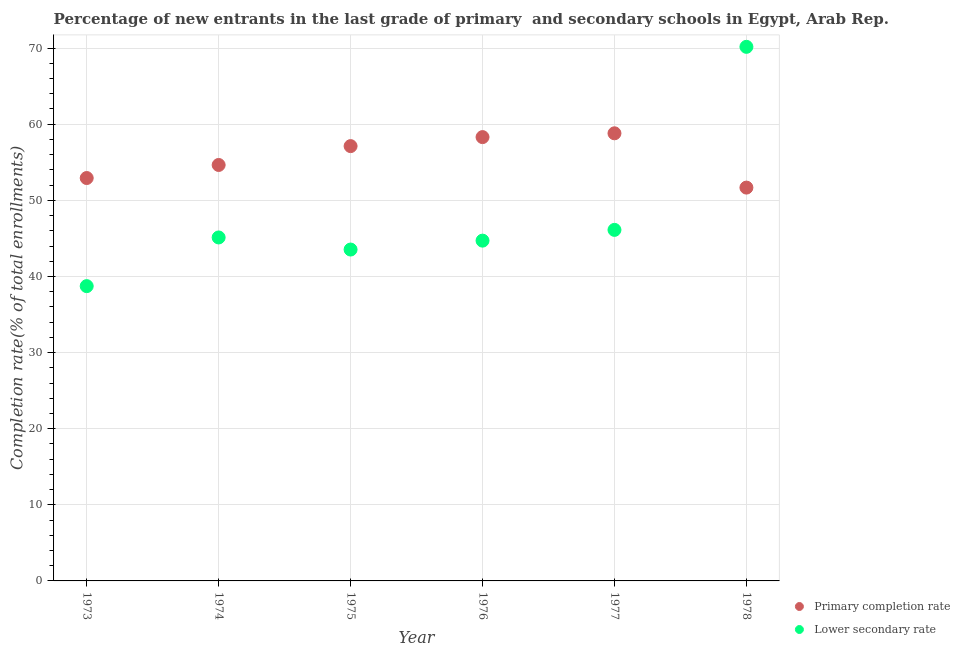What is the completion rate in secondary schools in 1975?
Ensure brevity in your answer.  43.53. Across all years, what is the maximum completion rate in secondary schools?
Your answer should be compact. 70.17. Across all years, what is the minimum completion rate in secondary schools?
Make the answer very short. 38.73. In which year was the completion rate in secondary schools maximum?
Your answer should be compact. 1978. In which year was the completion rate in primary schools minimum?
Your response must be concise. 1978. What is the total completion rate in secondary schools in the graph?
Offer a very short reply. 288.37. What is the difference between the completion rate in secondary schools in 1973 and that in 1976?
Keep it short and to the point. -5.98. What is the difference between the completion rate in secondary schools in 1976 and the completion rate in primary schools in 1977?
Keep it short and to the point. -14.1. What is the average completion rate in secondary schools per year?
Your answer should be very brief. 48.06. In the year 1975, what is the difference between the completion rate in secondary schools and completion rate in primary schools?
Keep it short and to the point. -13.59. In how many years, is the completion rate in secondary schools greater than 10 %?
Your answer should be compact. 6. What is the ratio of the completion rate in secondary schools in 1973 to that in 1975?
Your response must be concise. 0.89. What is the difference between the highest and the second highest completion rate in secondary schools?
Make the answer very short. 24.05. What is the difference between the highest and the lowest completion rate in primary schools?
Offer a terse response. 7.13. Does the completion rate in secondary schools monotonically increase over the years?
Offer a very short reply. No. Is the completion rate in secondary schools strictly greater than the completion rate in primary schools over the years?
Offer a terse response. No. Does the graph contain any zero values?
Your answer should be compact. No. Does the graph contain grids?
Your response must be concise. Yes. Where does the legend appear in the graph?
Your response must be concise. Bottom right. How many legend labels are there?
Your answer should be very brief. 2. What is the title of the graph?
Offer a terse response. Percentage of new entrants in the last grade of primary  and secondary schools in Egypt, Arab Rep. What is the label or title of the Y-axis?
Provide a succinct answer. Completion rate(% of total enrollments). What is the Completion rate(% of total enrollments) of Primary completion rate in 1973?
Provide a succinct answer. 52.93. What is the Completion rate(% of total enrollments) in Lower secondary rate in 1973?
Make the answer very short. 38.73. What is the Completion rate(% of total enrollments) in Primary completion rate in 1974?
Your response must be concise. 54.65. What is the Completion rate(% of total enrollments) in Lower secondary rate in 1974?
Your answer should be compact. 45.12. What is the Completion rate(% of total enrollments) of Primary completion rate in 1975?
Provide a succinct answer. 57.12. What is the Completion rate(% of total enrollments) in Lower secondary rate in 1975?
Provide a short and direct response. 43.53. What is the Completion rate(% of total enrollments) of Primary completion rate in 1976?
Make the answer very short. 58.31. What is the Completion rate(% of total enrollments) of Lower secondary rate in 1976?
Your response must be concise. 44.7. What is the Completion rate(% of total enrollments) in Primary completion rate in 1977?
Give a very brief answer. 58.81. What is the Completion rate(% of total enrollments) of Lower secondary rate in 1977?
Keep it short and to the point. 46.12. What is the Completion rate(% of total enrollments) of Primary completion rate in 1978?
Your answer should be very brief. 51.67. What is the Completion rate(% of total enrollments) in Lower secondary rate in 1978?
Your answer should be compact. 70.17. Across all years, what is the maximum Completion rate(% of total enrollments) in Primary completion rate?
Make the answer very short. 58.81. Across all years, what is the maximum Completion rate(% of total enrollments) in Lower secondary rate?
Offer a terse response. 70.17. Across all years, what is the minimum Completion rate(% of total enrollments) of Primary completion rate?
Keep it short and to the point. 51.67. Across all years, what is the minimum Completion rate(% of total enrollments) in Lower secondary rate?
Keep it short and to the point. 38.73. What is the total Completion rate(% of total enrollments) of Primary completion rate in the graph?
Your answer should be compact. 333.48. What is the total Completion rate(% of total enrollments) in Lower secondary rate in the graph?
Your answer should be very brief. 288.37. What is the difference between the Completion rate(% of total enrollments) in Primary completion rate in 1973 and that in 1974?
Make the answer very short. -1.72. What is the difference between the Completion rate(% of total enrollments) in Lower secondary rate in 1973 and that in 1974?
Keep it short and to the point. -6.39. What is the difference between the Completion rate(% of total enrollments) of Primary completion rate in 1973 and that in 1975?
Your answer should be very brief. -4.19. What is the difference between the Completion rate(% of total enrollments) of Lower secondary rate in 1973 and that in 1975?
Offer a very short reply. -4.81. What is the difference between the Completion rate(% of total enrollments) in Primary completion rate in 1973 and that in 1976?
Ensure brevity in your answer.  -5.38. What is the difference between the Completion rate(% of total enrollments) of Lower secondary rate in 1973 and that in 1976?
Provide a succinct answer. -5.98. What is the difference between the Completion rate(% of total enrollments) in Primary completion rate in 1973 and that in 1977?
Give a very brief answer. -5.88. What is the difference between the Completion rate(% of total enrollments) in Lower secondary rate in 1973 and that in 1977?
Make the answer very short. -7.39. What is the difference between the Completion rate(% of total enrollments) in Primary completion rate in 1973 and that in 1978?
Keep it short and to the point. 1.26. What is the difference between the Completion rate(% of total enrollments) in Lower secondary rate in 1973 and that in 1978?
Give a very brief answer. -31.44. What is the difference between the Completion rate(% of total enrollments) of Primary completion rate in 1974 and that in 1975?
Offer a very short reply. -2.48. What is the difference between the Completion rate(% of total enrollments) in Lower secondary rate in 1974 and that in 1975?
Give a very brief answer. 1.59. What is the difference between the Completion rate(% of total enrollments) in Primary completion rate in 1974 and that in 1976?
Ensure brevity in your answer.  -3.66. What is the difference between the Completion rate(% of total enrollments) of Lower secondary rate in 1974 and that in 1976?
Offer a very short reply. 0.42. What is the difference between the Completion rate(% of total enrollments) of Primary completion rate in 1974 and that in 1977?
Provide a short and direct response. -4.16. What is the difference between the Completion rate(% of total enrollments) of Lower secondary rate in 1974 and that in 1977?
Your answer should be very brief. -0.99. What is the difference between the Completion rate(% of total enrollments) in Primary completion rate in 1974 and that in 1978?
Keep it short and to the point. 2.97. What is the difference between the Completion rate(% of total enrollments) in Lower secondary rate in 1974 and that in 1978?
Make the answer very short. -25.04. What is the difference between the Completion rate(% of total enrollments) of Primary completion rate in 1975 and that in 1976?
Make the answer very short. -1.18. What is the difference between the Completion rate(% of total enrollments) of Lower secondary rate in 1975 and that in 1976?
Ensure brevity in your answer.  -1.17. What is the difference between the Completion rate(% of total enrollments) in Primary completion rate in 1975 and that in 1977?
Provide a succinct answer. -1.68. What is the difference between the Completion rate(% of total enrollments) in Lower secondary rate in 1975 and that in 1977?
Ensure brevity in your answer.  -2.58. What is the difference between the Completion rate(% of total enrollments) of Primary completion rate in 1975 and that in 1978?
Give a very brief answer. 5.45. What is the difference between the Completion rate(% of total enrollments) in Lower secondary rate in 1975 and that in 1978?
Ensure brevity in your answer.  -26.63. What is the difference between the Completion rate(% of total enrollments) in Primary completion rate in 1976 and that in 1977?
Make the answer very short. -0.5. What is the difference between the Completion rate(% of total enrollments) in Lower secondary rate in 1976 and that in 1977?
Offer a very short reply. -1.41. What is the difference between the Completion rate(% of total enrollments) of Primary completion rate in 1976 and that in 1978?
Your answer should be compact. 6.63. What is the difference between the Completion rate(% of total enrollments) of Lower secondary rate in 1976 and that in 1978?
Make the answer very short. -25.46. What is the difference between the Completion rate(% of total enrollments) of Primary completion rate in 1977 and that in 1978?
Ensure brevity in your answer.  7.13. What is the difference between the Completion rate(% of total enrollments) of Lower secondary rate in 1977 and that in 1978?
Your answer should be compact. -24.05. What is the difference between the Completion rate(% of total enrollments) of Primary completion rate in 1973 and the Completion rate(% of total enrollments) of Lower secondary rate in 1974?
Your answer should be compact. 7.81. What is the difference between the Completion rate(% of total enrollments) in Primary completion rate in 1973 and the Completion rate(% of total enrollments) in Lower secondary rate in 1975?
Offer a very short reply. 9.4. What is the difference between the Completion rate(% of total enrollments) in Primary completion rate in 1973 and the Completion rate(% of total enrollments) in Lower secondary rate in 1976?
Give a very brief answer. 8.23. What is the difference between the Completion rate(% of total enrollments) of Primary completion rate in 1973 and the Completion rate(% of total enrollments) of Lower secondary rate in 1977?
Keep it short and to the point. 6.81. What is the difference between the Completion rate(% of total enrollments) in Primary completion rate in 1973 and the Completion rate(% of total enrollments) in Lower secondary rate in 1978?
Make the answer very short. -17.23. What is the difference between the Completion rate(% of total enrollments) of Primary completion rate in 1974 and the Completion rate(% of total enrollments) of Lower secondary rate in 1975?
Give a very brief answer. 11.11. What is the difference between the Completion rate(% of total enrollments) in Primary completion rate in 1974 and the Completion rate(% of total enrollments) in Lower secondary rate in 1976?
Give a very brief answer. 9.94. What is the difference between the Completion rate(% of total enrollments) in Primary completion rate in 1974 and the Completion rate(% of total enrollments) in Lower secondary rate in 1977?
Your answer should be compact. 8.53. What is the difference between the Completion rate(% of total enrollments) in Primary completion rate in 1974 and the Completion rate(% of total enrollments) in Lower secondary rate in 1978?
Your answer should be very brief. -15.52. What is the difference between the Completion rate(% of total enrollments) of Primary completion rate in 1975 and the Completion rate(% of total enrollments) of Lower secondary rate in 1976?
Ensure brevity in your answer.  12.42. What is the difference between the Completion rate(% of total enrollments) in Primary completion rate in 1975 and the Completion rate(% of total enrollments) in Lower secondary rate in 1977?
Make the answer very short. 11.01. What is the difference between the Completion rate(% of total enrollments) in Primary completion rate in 1975 and the Completion rate(% of total enrollments) in Lower secondary rate in 1978?
Give a very brief answer. -13.04. What is the difference between the Completion rate(% of total enrollments) of Primary completion rate in 1976 and the Completion rate(% of total enrollments) of Lower secondary rate in 1977?
Your answer should be compact. 12.19. What is the difference between the Completion rate(% of total enrollments) in Primary completion rate in 1976 and the Completion rate(% of total enrollments) in Lower secondary rate in 1978?
Offer a very short reply. -11.86. What is the difference between the Completion rate(% of total enrollments) of Primary completion rate in 1977 and the Completion rate(% of total enrollments) of Lower secondary rate in 1978?
Your answer should be very brief. -11.36. What is the average Completion rate(% of total enrollments) of Primary completion rate per year?
Give a very brief answer. 55.58. What is the average Completion rate(% of total enrollments) in Lower secondary rate per year?
Provide a succinct answer. 48.06. In the year 1973, what is the difference between the Completion rate(% of total enrollments) of Primary completion rate and Completion rate(% of total enrollments) of Lower secondary rate?
Your answer should be compact. 14.2. In the year 1974, what is the difference between the Completion rate(% of total enrollments) in Primary completion rate and Completion rate(% of total enrollments) in Lower secondary rate?
Make the answer very short. 9.52. In the year 1975, what is the difference between the Completion rate(% of total enrollments) of Primary completion rate and Completion rate(% of total enrollments) of Lower secondary rate?
Make the answer very short. 13.59. In the year 1976, what is the difference between the Completion rate(% of total enrollments) in Primary completion rate and Completion rate(% of total enrollments) in Lower secondary rate?
Your response must be concise. 13.6. In the year 1977, what is the difference between the Completion rate(% of total enrollments) of Primary completion rate and Completion rate(% of total enrollments) of Lower secondary rate?
Provide a short and direct response. 12.69. In the year 1978, what is the difference between the Completion rate(% of total enrollments) in Primary completion rate and Completion rate(% of total enrollments) in Lower secondary rate?
Provide a short and direct response. -18.49. What is the ratio of the Completion rate(% of total enrollments) of Primary completion rate in 1973 to that in 1974?
Keep it short and to the point. 0.97. What is the ratio of the Completion rate(% of total enrollments) in Lower secondary rate in 1973 to that in 1974?
Make the answer very short. 0.86. What is the ratio of the Completion rate(% of total enrollments) in Primary completion rate in 1973 to that in 1975?
Keep it short and to the point. 0.93. What is the ratio of the Completion rate(% of total enrollments) in Lower secondary rate in 1973 to that in 1975?
Provide a succinct answer. 0.89. What is the ratio of the Completion rate(% of total enrollments) in Primary completion rate in 1973 to that in 1976?
Offer a very short reply. 0.91. What is the ratio of the Completion rate(% of total enrollments) in Lower secondary rate in 1973 to that in 1976?
Provide a short and direct response. 0.87. What is the ratio of the Completion rate(% of total enrollments) in Primary completion rate in 1973 to that in 1977?
Keep it short and to the point. 0.9. What is the ratio of the Completion rate(% of total enrollments) of Lower secondary rate in 1973 to that in 1977?
Give a very brief answer. 0.84. What is the ratio of the Completion rate(% of total enrollments) in Primary completion rate in 1973 to that in 1978?
Offer a very short reply. 1.02. What is the ratio of the Completion rate(% of total enrollments) in Lower secondary rate in 1973 to that in 1978?
Make the answer very short. 0.55. What is the ratio of the Completion rate(% of total enrollments) of Primary completion rate in 1974 to that in 1975?
Your response must be concise. 0.96. What is the ratio of the Completion rate(% of total enrollments) of Lower secondary rate in 1974 to that in 1975?
Your response must be concise. 1.04. What is the ratio of the Completion rate(% of total enrollments) in Primary completion rate in 1974 to that in 1976?
Offer a very short reply. 0.94. What is the ratio of the Completion rate(% of total enrollments) in Lower secondary rate in 1974 to that in 1976?
Ensure brevity in your answer.  1.01. What is the ratio of the Completion rate(% of total enrollments) in Primary completion rate in 1974 to that in 1977?
Keep it short and to the point. 0.93. What is the ratio of the Completion rate(% of total enrollments) of Lower secondary rate in 1974 to that in 1977?
Provide a succinct answer. 0.98. What is the ratio of the Completion rate(% of total enrollments) in Primary completion rate in 1974 to that in 1978?
Make the answer very short. 1.06. What is the ratio of the Completion rate(% of total enrollments) of Lower secondary rate in 1974 to that in 1978?
Give a very brief answer. 0.64. What is the ratio of the Completion rate(% of total enrollments) of Primary completion rate in 1975 to that in 1976?
Your answer should be compact. 0.98. What is the ratio of the Completion rate(% of total enrollments) in Lower secondary rate in 1975 to that in 1976?
Provide a short and direct response. 0.97. What is the ratio of the Completion rate(% of total enrollments) of Primary completion rate in 1975 to that in 1977?
Your answer should be compact. 0.97. What is the ratio of the Completion rate(% of total enrollments) of Lower secondary rate in 1975 to that in 1977?
Provide a succinct answer. 0.94. What is the ratio of the Completion rate(% of total enrollments) of Primary completion rate in 1975 to that in 1978?
Your answer should be very brief. 1.11. What is the ratio of the Completion rate(% of total enrollments) in Lower secondary rate in 1975 to that in 1978?
Make the answer very short. 0.62. What is the ratio of the Completion rate(% of total enrollments) of Lower secondary rate in 1976 to that in 1977?
Ensure brevity in your answer.  0.97. What is the ratio of the Completion rate(% of total enrollments) in Primary completion rate in 1976 to that in 1978?
Make the answer very short. 1.13. What is the ratio of the Completion rate(% of total enrollments) in Lower secondary rate in 1976 to that in 1978?
Offer a terse response. 0.64. What is the ratio of the Completion rate(% of total enrollments) in Primary completion rate in 1977 to that in 1978?
Make the answer very short. 1.14. What is the ratio of the Completion rate(% of total enrollments) in Lower secondary rate in 1977 to that in 1978?
Offer a very short reply. 0.66. What is the difference between the highest and the second highest Completion rate(% of total enrollments) in Primary completion rate?
Your response must be concise. 0.5. What is the difference between the highest and the second highest Completion rate(% of total enrollments) in Lower secondary rate?
Provide a succinct answer. 24.05. What is the difference between the highest and the lowest Completion rate(% of total enrollments) in Primary completion rate?
Make the answer very short. 7.13. What is the difference between the highest and the lowest Completion rate(% of total enrollments) of Lower secondary rate?
Your answer should be compact. 31.44. 